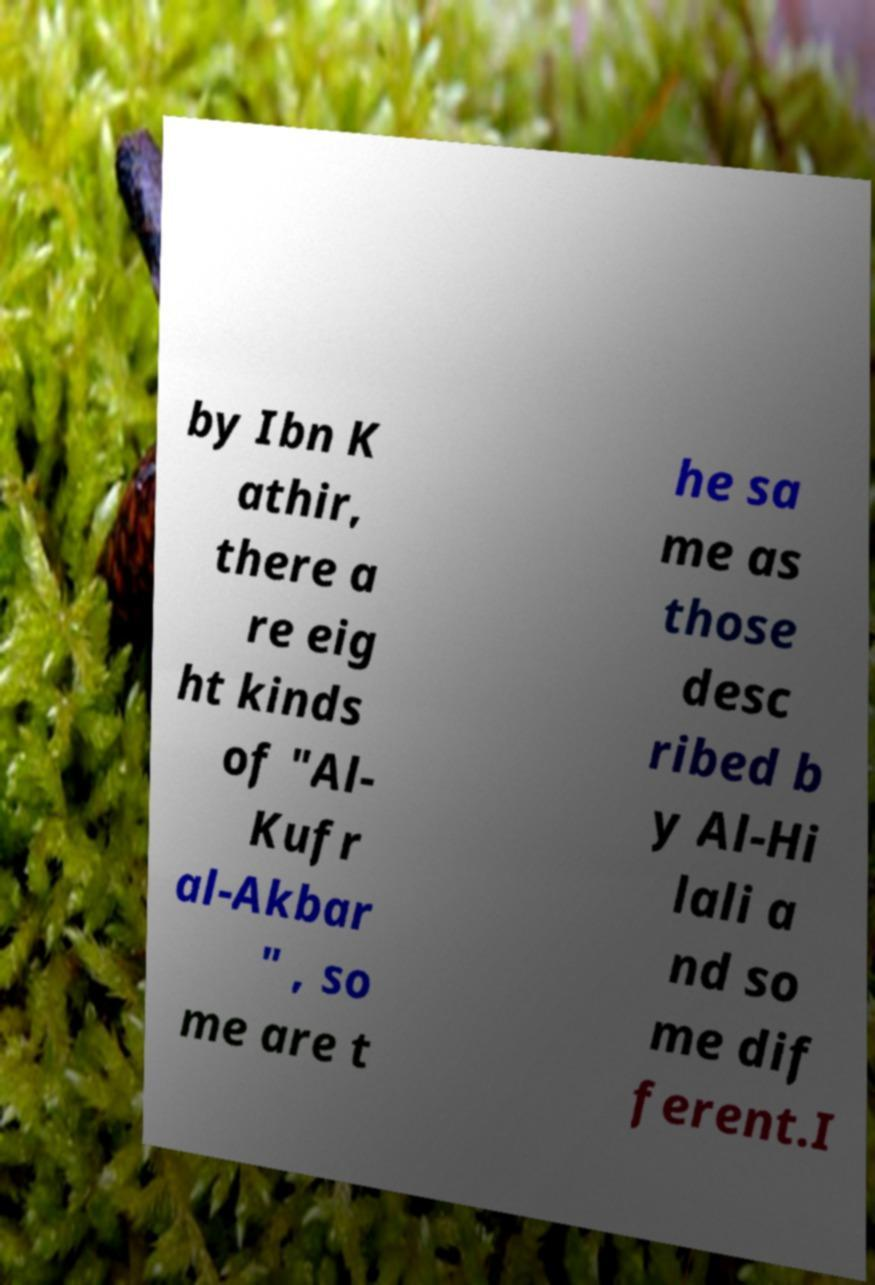What messages or text are displayed in this image? I need them in a readable, typed format. by Ibn K athir, there a re eig ht kinds of "Al- Kufr al-Akbar " , so me are t he sa me as those desc ribed b y Al-Hi lali a nd so me dif ferent.I 